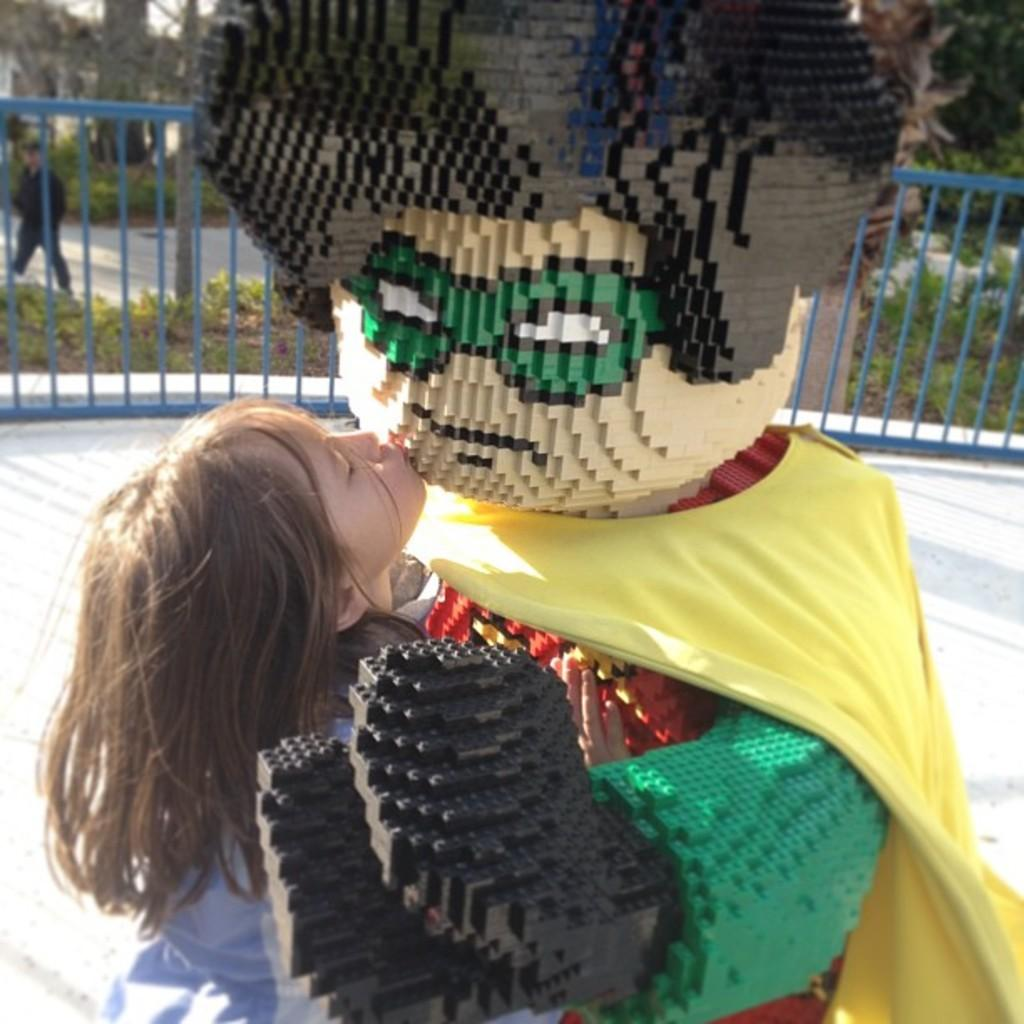Who is the main subject in the image? There is a girl in the image. What is the girl holding in the image? The girl is holding a doll with a costume in the image. What can be seen in the background of the image? There is a fence, plants, a person, and a tree trunk visible in the background of the image. How is the background of the image depicted? The background of the image is blurry. What type of book is the girl reading in the image? There is no book present in the image, and the girl is not reading. What topic is the person in the background discussing with the girl? There is no conversation depicted in the image, so it is not possible to determine what the person in the background might be discussing with the girl. 